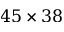Convert formula to latex. <formula><loc_0><loc_0><loc_500><loc_500>4 5 \times 3 8</formula> 